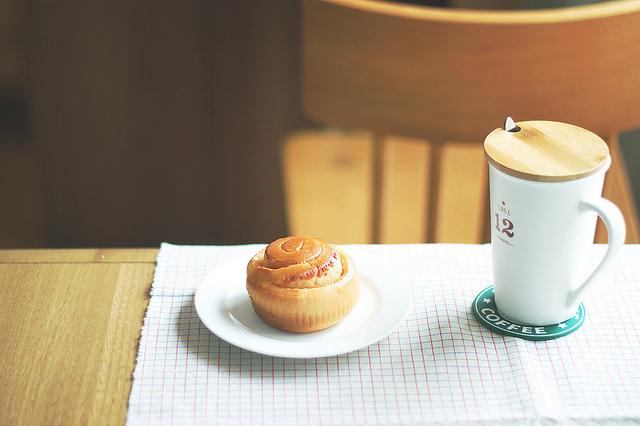What brand of coffee is this?
Quick response, please. Starbucks. What is the table made out of?
Keep it brief. Wood. What is the muffin sitting on?
Be succinct. Plate. 